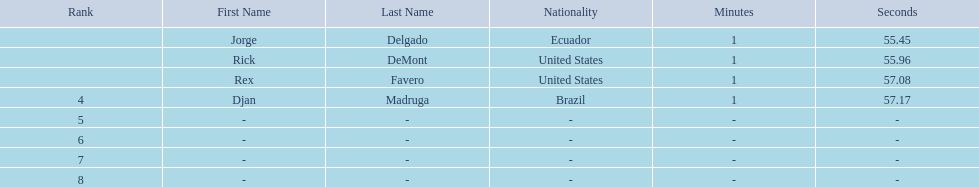What is the average time? 1:56.42. 